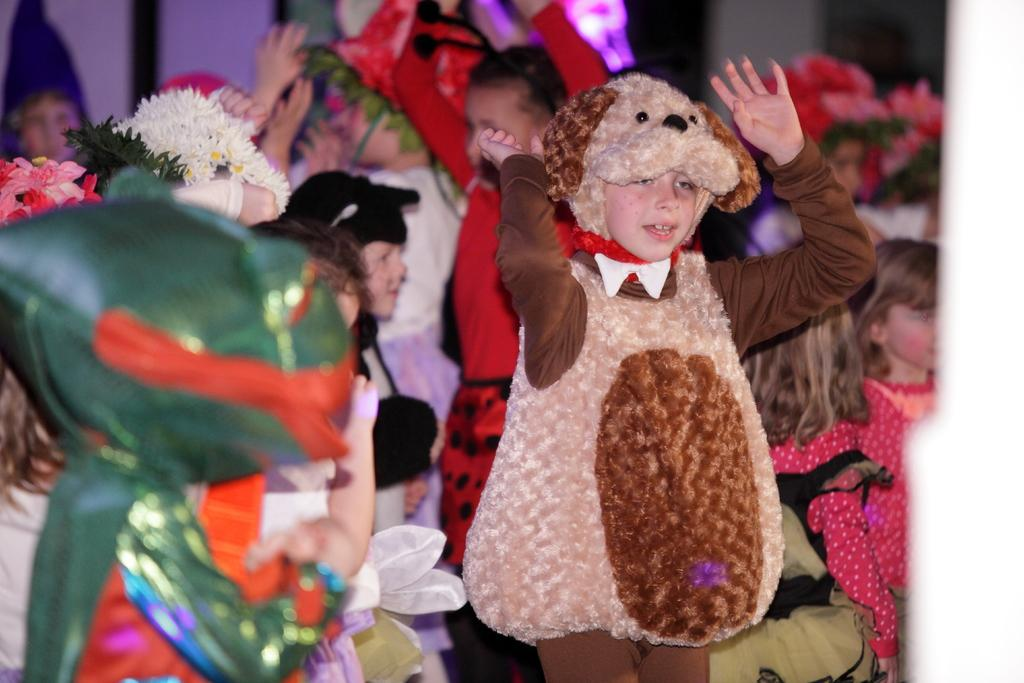What can be seen in the image? There are kids in the image. What are the kids wearing? The kids are wearing different costumes. What are the kids doing in the image? The kids are standing in the image. What type of pencil can be seen in the hands of the kids in the image? There are no pencils present in the image; the kids are wearing costumes and standing. What pets are accompanying the kids in the image? There are no pets present in the image; it only features kids wearing costumes and standing. 